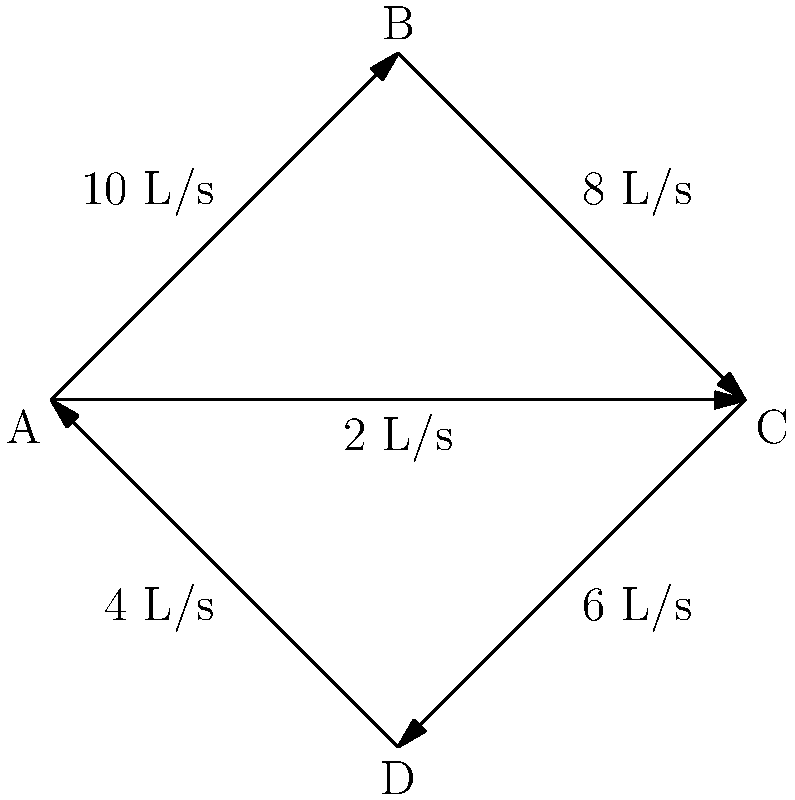Given the water distribution system represented by the network graph, where each node represents a junction and each edge represents a pipe with its flow rate, determine the total outflow from node C. Assume that water flows in the direction of the arrows. To solve this problem, we need to apply the concept of conservation of mass (or in this case, conservation of flow) at node C. This principle states that the total inflow must equal the total outflow at any given node in a steady-state system.

Let's follow these steps:

1. Identify the inflows to node C:
   - From node B: 8 L/s
   - From node A: 2 L/s
   Total inflow = 8 + 2 = 10 L/s

2. Identify the known outflow from node C:
   - To node D: 6 L/s

3. Apply the conservation of flow principle:
   Total inflow = Total outflow
   10 L/s = 6 L/s + x, where x is the unknown additional outflow

4. Solve for x:
   x = 10 L/s - 6 L/s = 4 L/s

5. Calculate the total outflow:
   Total outflow = Known outflow + Calculated additional outflow
   Total outflow = 6 L/s + 4 L/s = 10 L/s

Therefore, the total outflow from node C is 10 L/s, which matches the total inflow, satisfying the conservation of flow principle.
Answer: 10 L/s 